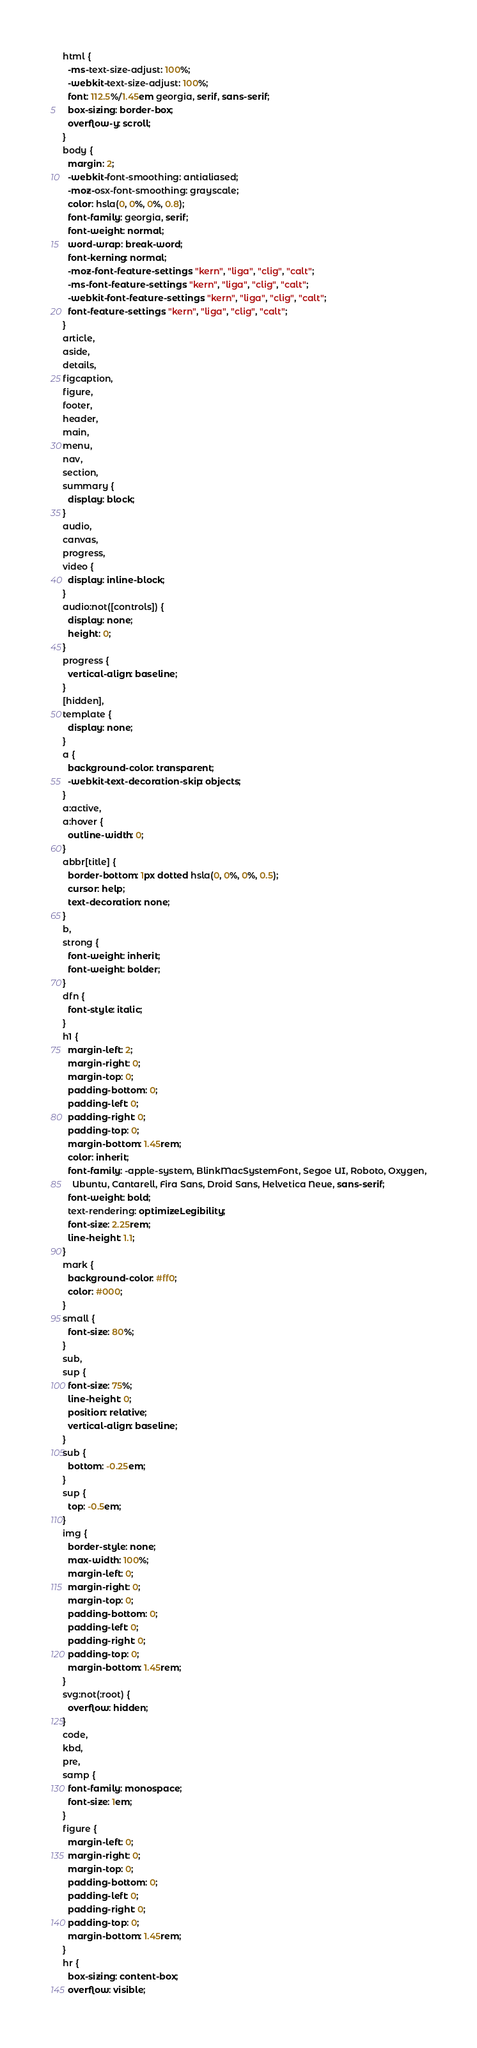Convert code to text. <code><loc_0><loc_0><loc_500><loc_500><_CSS_>html {
  -ms-text-size-adjust: 100%;
  -webkit-text-size-adjust: 100%;
  font: 112.5%/1.45em georgia, serif, sans-serif;
  box-sizing: border-box;
  overflow-y: scroll;
}
body {
  margin: 2;
  -webkit-font-smoothing: antialiased;
  -moz-osx-font-smoothing: grayscale;
  color: hsla(0, 0%, 0%, 0.8);
  font-family: georgia, serif;
  font-weight: normal;
  word-wrap: break-word;
  font-kerning: normal;
  -moz-font-feature-settings: "kern", "liga", "clig", "calt";
  -ms-font-feature-settings: "kern", "liga", "clig", "calt";
  -webkit-font-feature-settings: "kern", "liga", "clig", "calt";
  font-feature-settings: "kern", "liga", "clig", "calt";
}
article,
aside,
details,
figcaption,
figure,
footer,
header,
main,
menu,
nav,
section,
summary {
  display: block;
}
audio,
canvas,
progress,
video {
  display: inline-block;
}
audio:not([controls]) {
  display: none;
  height: 0;
}
progress {
  vertical-align: baseline;
}
[hidden],
template {
  display: none;
}
a {
  background-color: transparent;
  -webkit-text-decoration-skip: objects;
}
a:active,
a:hover {
  outline-width: 0;
}
abbr[title] {
  border-bottom: 1px dotted hsla(0, 0%, 0%, 0.5);
  cursor: help;
  text-decoration: none;
}
b,
strong {
  font-weight: inherit;
  font-weight: bolder;
}
dfn {
  font-style: italic;
}
h1 {
  margin-left: 2;
  margin-right: 0;
  margin-top: 0;
  padding-bottom: 0;
  padding-left: 0;
  padding-right: 0;
  padding-top: 0;
  margin-bottom: 1.45rem;
  color: inherit;
  font-family: -apple-system, BlinkMacSystemFont, Segoe UI, Roboto, Oxygen,
    Ubuntu, Cantarell, Fira Sans, Droid Sans, Helvetica Neue, sans-serif;
  font-weight: bold;
  text-rendering: optimizeLegibility;
  font-size: 2.25rem;
  line-height: 1.1;
}
mark {
  background-color: #ff0;
  color: #000;
}
small {
  font-size: 80%;
}
sub,
sup {
  font-size: 75%;
  line-height: 0;
  position: relative;
  vertical-align: baseline;
}
sub {
  bottom: -0.25em;
}
sup {
  top: -0.5em;
}
img {
  border-style: none;
  max-width: 100%;
  margin-left: 0;
  margin-right: 0;
  margin-top: 0;
  padding-bottom: 0;
  padding-left: 0;
  padding-right: 0;
  padding-top: 0;
  margin-bottom: 1.45rem;
}
svg:not(:root) {
  overflow: hidden;
}
code,
kbd,
pre,
samp {
  font-family: monospace;
  font-size: 1em;
}
figure {
  margin-left: 0;
  margin-right: 0;
  margin-top: 0;
  padding-bottom: 0;
  padding-left: 0;
  padding-right: 0;
  padding-top: 0;
  margin-bottom: 1.45rem;
}
hr {
  box-sizing: content-box;
  overflow: visible;</code> 